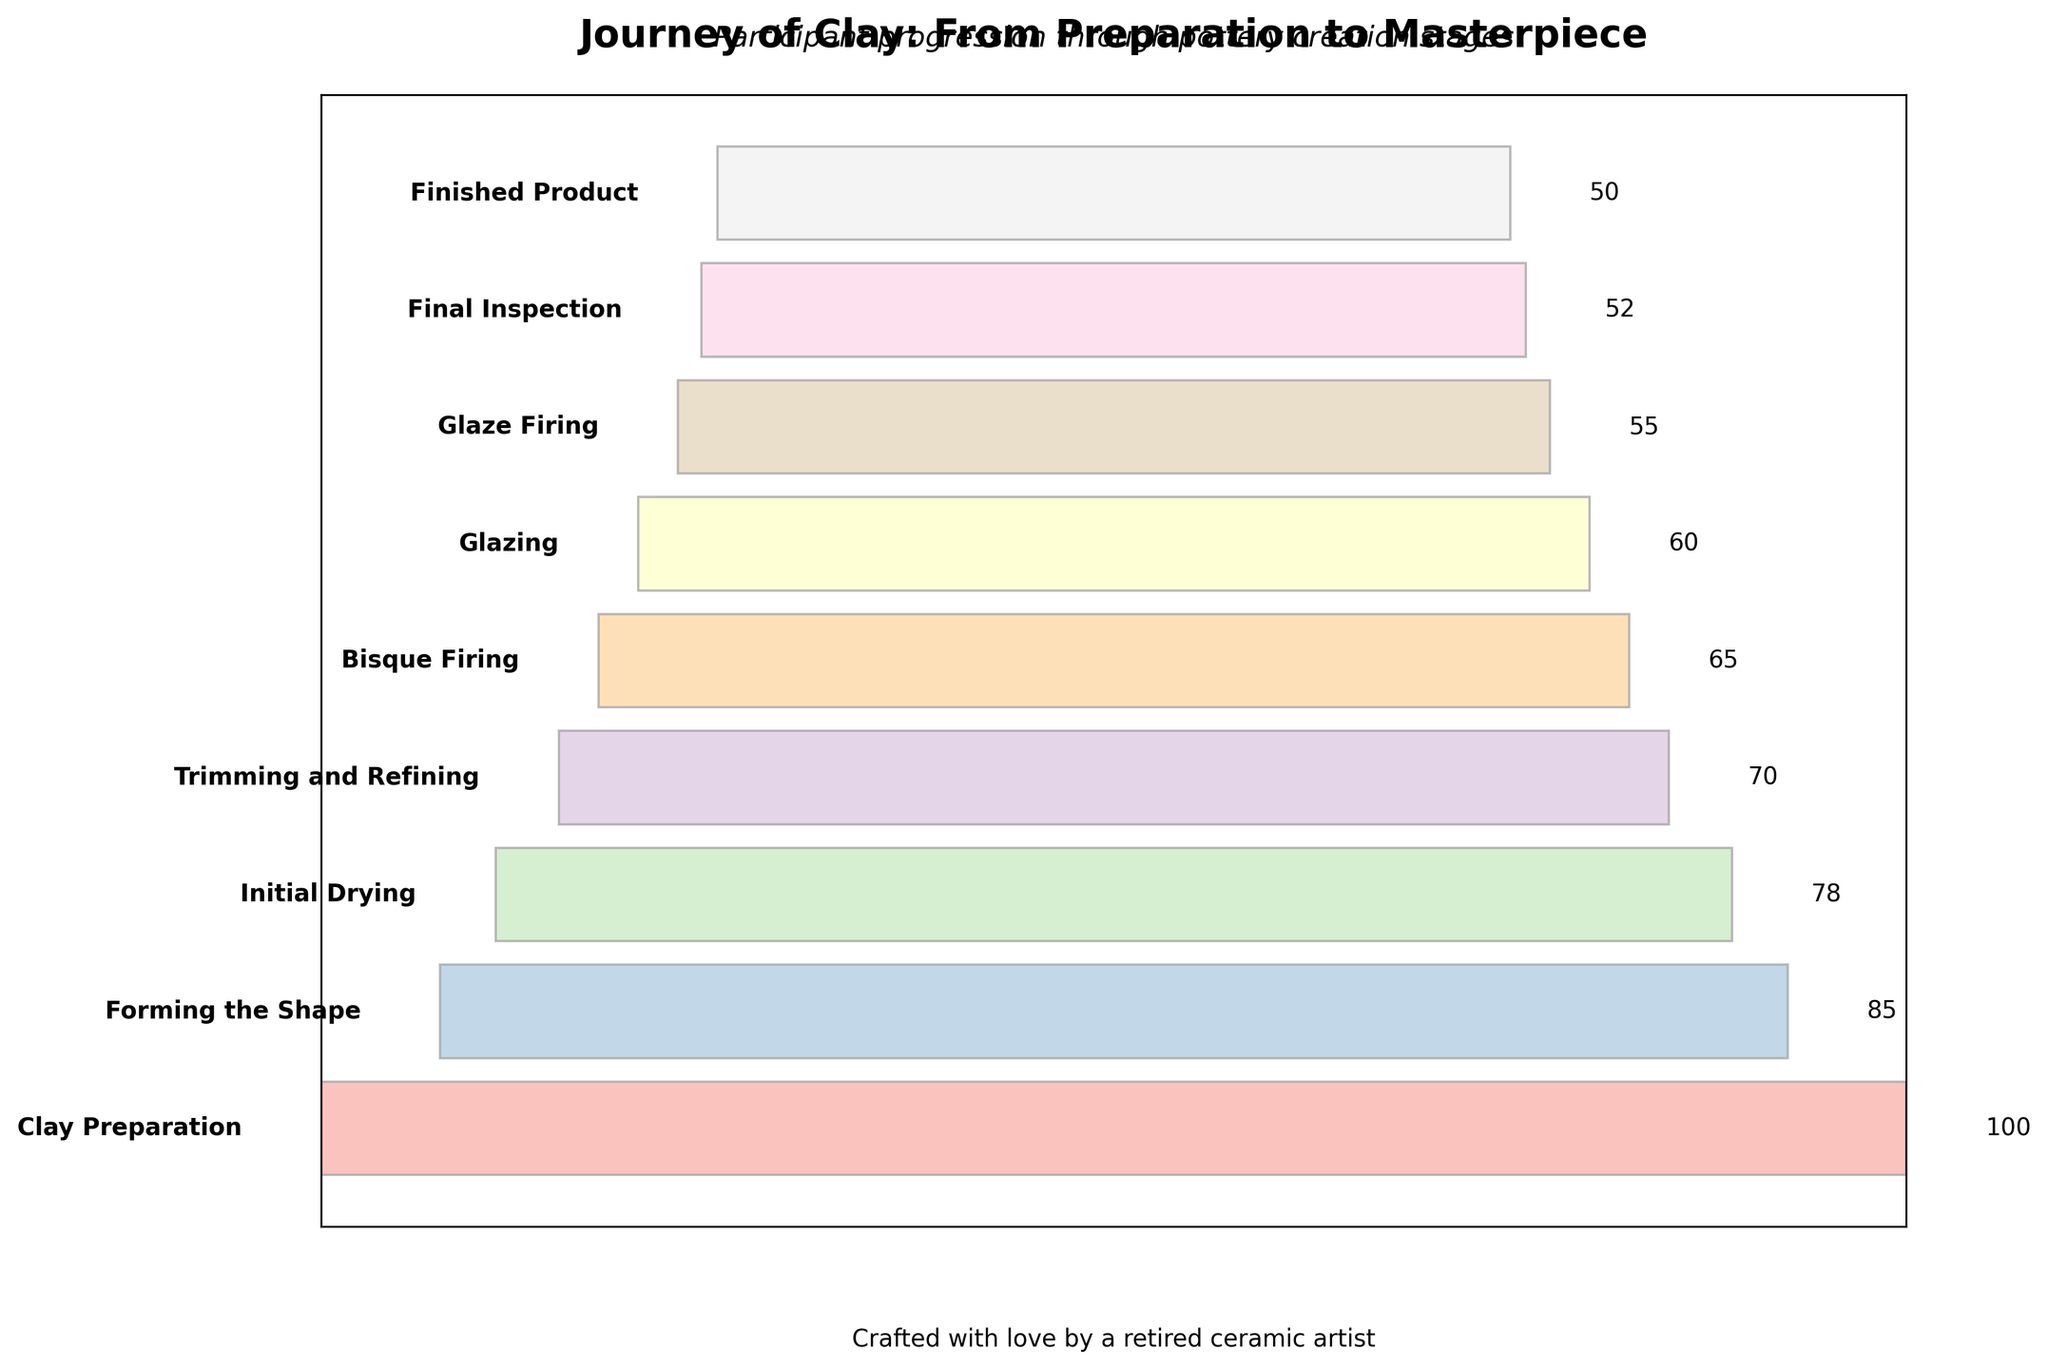How many stages are there in the pottery creation process? The plot lists stages from "Clay Preparation" to "Finished Product" and each stage is represented as a bar on the funnel chart.
Answer: 9 What is the title of the chart? The title is shown at the top of the chart.
Answer: Journey of Clay: From Preparation to Masterpiece Which stage involves the highest number of participants? The stage with the longest bar length represents the highest number of participants.
Answer: Clay Preparation How many participants are involved in the Glazing stage? The number is indicated next to the Glazing stage bar.
Answer: 60 What is the difference in the number of participants between 'Trimming and Refining' and 'Bisque Firing' stages? Subtract the number of participants in 'Bisque Firing' (65) from 'Trimming and Refining' (70). 70 - 65 = 5.
Answer: 5 What is the sum of participants at stages 'Initial Drying' and 'Final Inspection'? Add the number of participants in 'Initial Drying' (78) and 'Final Inspection' (52). 78 + 52 = 130.
Answer: 130 Are there more participants in the 'Forming the Shape' stage or the 'Glaze Firing' stage? Compare the number of participants in 'Forming the Shape' (85) with 'Glaze Firing' (55).
Answer: Forming the Shape Is the number of participants in 'Finished Product' stage closer to 'Final Inspection' or 'Glaze Firing'? Calculate the difference between 'Finished Product' (50) and 'Final Inspection' (52), and 'Finished Product' and 'Glaze Firing' (55). (52-50)=2 and (55-50)=5, 2<5, hence closer to 'Final Inspection'.
Answer: Final Inspection What percentage of participants drop out after 'Forming the Shape' stage? The number drops from 85 (Forming the Shape) to 78 (Initial Drying). Calculate the percentage drop: ((85-78)/85)*100 = (7/85)*100 ≈ 8.24%.
Answer: 8.24% Between which two consecutive stages is the biggest drop in the number of participants? Calculate the drops between each consecutive stage: 
1) Clay Preparation to Forming the Shape: 100 - 85 = 15
2) Forming the Shape to Initial Drying: 85 - 78 = 7
3) Initial Drying to Trimming and Refining: 78 - 70 = 8
4) Trimming and Refining to Bisque Firing: 70 - 65 = 5
5) Bisque Firing to Glazing: 65 - 60 = 5
6) Glazing to Glaze Firing: 60 - 55 = 5
7) Glaze Firing to Final Inspection: 55 - 52 = 3
8) Final Inspection to Finished Product: 52 - 50 = 2. The biggest drop is 15 between 'Clay Preparation' and 'Forming the Shape'.
Answer: Clay Preparation and Forming the Shape 